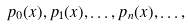Convert formula to latex. <formula><loc_0><loc_0><loc_500><loc_500>p _ { 0 } ( x ) , p _ { 1 } ( x ) , \dots , p _ { n } ( x ) , \dots ,</formula> 